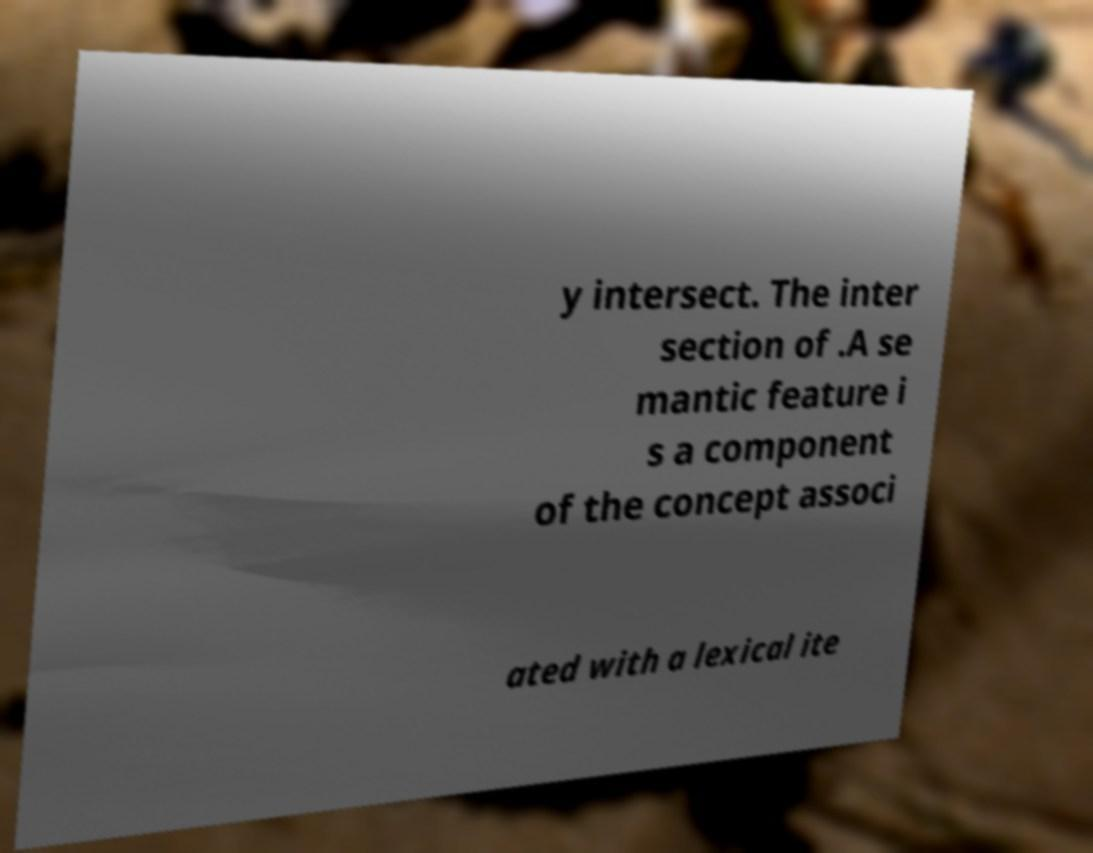Could you extract and type out the text from this image? y intersect. The inter section of .A se mantic feature i s a component of the concept associ ated with a lexical ite 